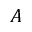Convert formula to latex. <formula><loc_0><loc_0><loc_500><loc_500>A</formula> 